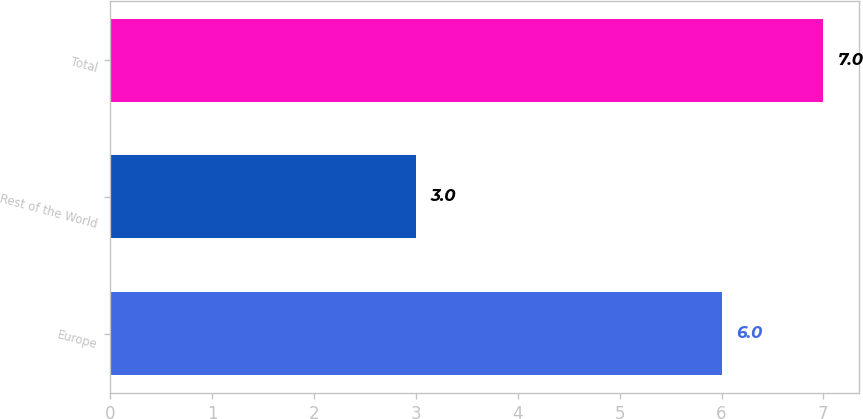Convert chart. <chart><loc_0><loc_0><loc_500><loc_500><bar_chart><fcel>Europe<fcel>Rest of the World<fcel>Total<nl><fcel>6<fcel>3<fcel>7<nl></chart> 